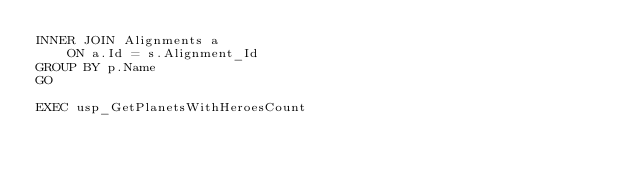<code> <loc_0><loc_0><loc_500><loc_500><_SQL_>INNER JOIN Alignments a
	ON a.Id = s.Alignment_Id
GROUP BY p.Name
GO

EXEC usp_GetPlanetsWithHeroesCount</code> 